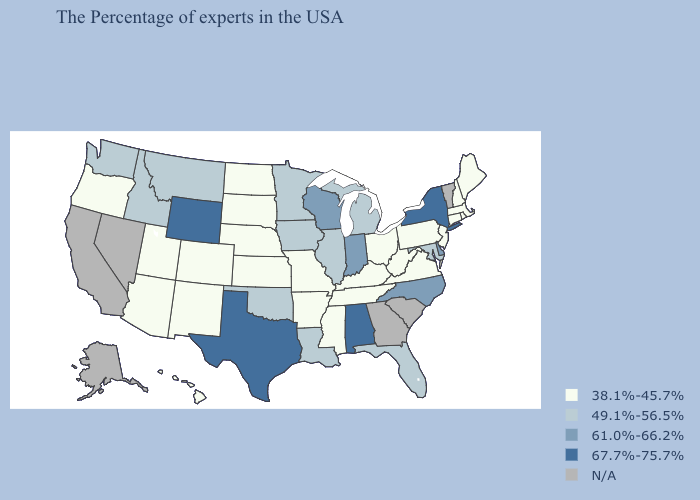Which states have the highest value in the USA?
Give a very brief answer. New York, Alabama, Texas, Wyoming. What is the value of Michigan?
Answer briefly. 49.1%-56.5%. Which states hav the highest value in the Northeast?
Write a very short answer. New York. Does Hawaii have the lowest value in the West?
Keep it brief. Yes. Among the states that border Vermont , does Massachusetts have the lowest value?
Answer briefly. Yes. Among the states that border North Carolina , which have the lowest value?
Give a very brief answer. Virginia, Tennessee. Name the states that have a value in the range 67.7%-75.7%?
Answer briefly. New York, Alabama, Texas, Wyoming. How many symbols are there in the legend?
Give a very brief answer. 5. Among the states that border Michigan , which have the highest value?
Give a very brief answer. Indiana, Wisconsin. Does the map have missing data?
Keep it brief. Yes. What is the highest value in the USA?
Quick response, please. 67.7%-75.7%. Name the states that have a value in the range 67.7%-75.7%?
Quick response, please. New York, Alabama, Texas, Wyoming. What is the value of Florida?
Quick response, please. 49.1%-56.5%. Name the states that have a value in the range 38.1%-45.7%?
Short answer required. Maine, Massachusetts, Rhode Island, New Hampshire, Connecticut, New Jersey, Pennsylvania, Virginia, West Virginia, Ohio, Kentucky, Tennessee, Mississippi, Missouri, Arkansas, Kansas, Nebraska, South Dakota, North Dakota, Colorado, New Mexico, Utah, Arizona, Oregon, Hawaii. 